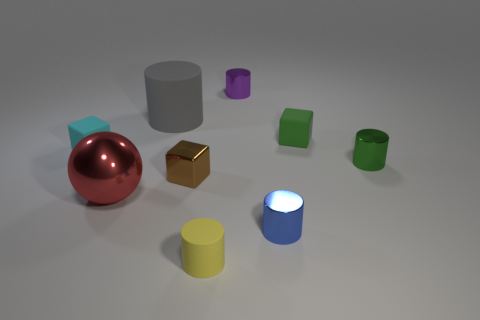Is the number of green metal cylinders that are in front of the yellow matte object greater than the number of red blocks?
Keep it short and to the point. No. Are there any small blue things that have the same material as the tiny brown block?
Provide a short and direct response. Yes. There is a metallic object that is left of the big gray matte object; does it have the same shape as the big gray thing?
Make the answer very short. No. There is a tiny rubber cube left of the small block in front of the green metallic object; what number of green objects are in front of it?
Provide a succinct answer. 1. Is the number of tiny green shiny cylinders in front of the red object less than the number of blue cylinders that are in front of the blue metal object?
Offer a very short reply. No. What color is the small rubber object that is the same shape as the small green metal thing?
Your response must be concise. Yellow. The metallic ball is what size?
Your answer should be very brief. Large. How many green matte things have the same size as the cyan thing?
Ensure brevity in your answer.  1. Is the metal ball the same color as the tiny metallic block?
Keep it short and to the point. No. Is the material of the tiny cube on the left side of the big gray cylinder the same as the big object behind the large shiny object?
Give a very brief answer. Yes. 